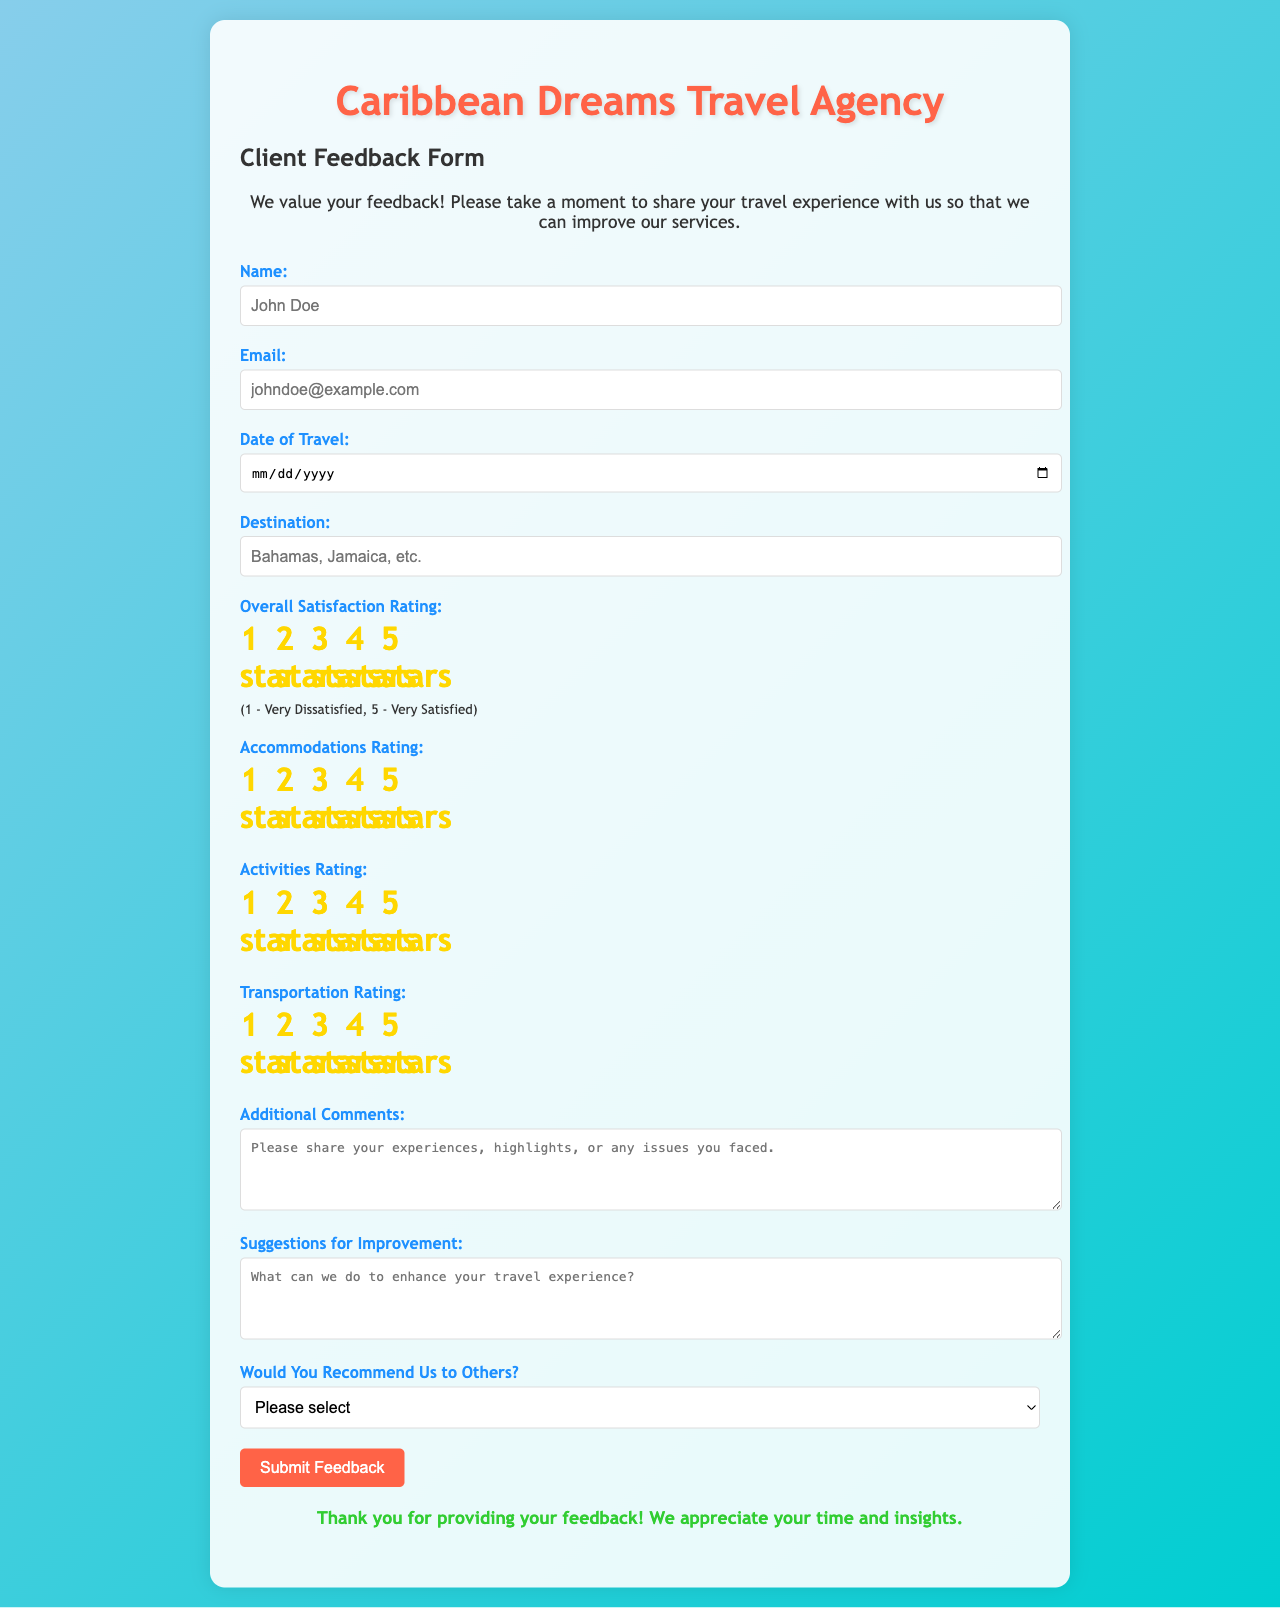What is the title of the document? The title of the document is specified in the title tag of the HTML, which describes the travel agency and the purpose of the form.
Answer: Caribbean Dreams Travel Agency - Client Feedback Form What type of feedback does the form request? The form specifically asks for client feedback regarding their travel experience and suggestions for improvement.
Answer: Client feedback How many star ratings are available for overall satisfaction? The document describes a rating system that offers five possible selections for overall satisfaction, ranging from one to five stars.
Answer: Five What is the placeholder text for the name input field? The placeholder for the name input field provides an example to guide the user on what to enter.
Answer: John Doe What is the color of the main heading text? The main heading color is mentioned in the CSS, which defines various styles for text elements in the document.
Answer: Tomato What does the document ask for regarding transportation? The feedback form includes a specific section for users to rate their transportation experience during travel.
Answer: Transportation Rating Is there a section for additional comments? The form includes a dedicated text area for clients to share their experiences, issues, or highlights related to their travel.
Answer: Yes What is the minimum requirement for the email field? The email input field is marked as required, indicating that clients must provide a valid email address to complete the form.
Answer: Required How does the form address the possibility of recommending the agency? The form includes a select dropdown asking clients whether they would recommend the travel agency to others.
Answer: Would You Recommend Us to Others? 